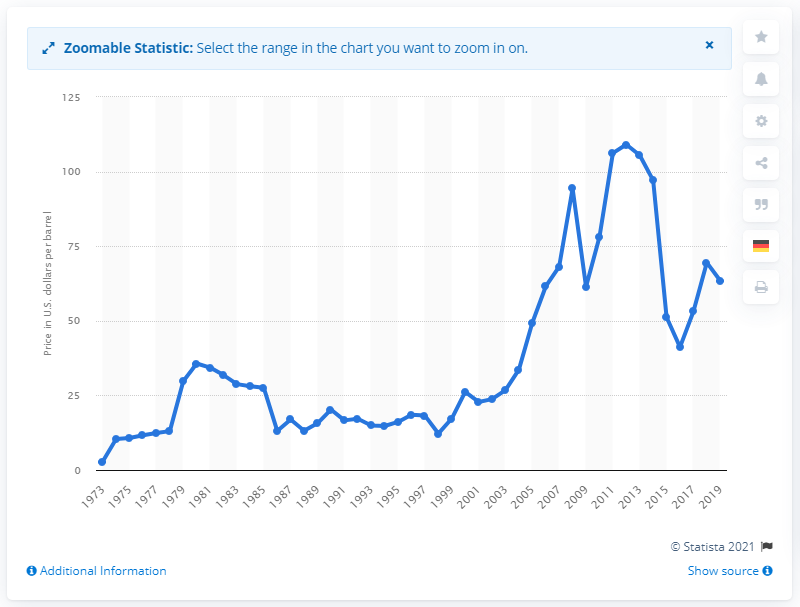Outline some significant characteristics in this image. Dubai Fateh's average price per barrel is 63.43. 